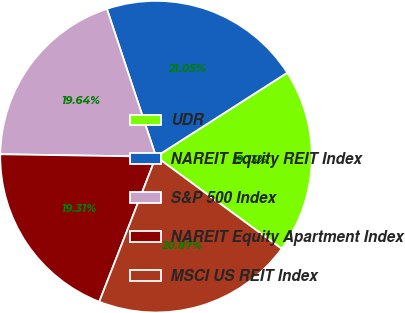Convert chart. <chart><loc_0><loc_0><loc_500><loc_500><pie_chart><fcel>UDR<fcel>NAREIT Equity REIT Index<fcel>S&P 500 Index<fcel>NAREIT Equity Apartment Index<fcel>MSCI US REIT Index<nl><fcel>19.13%<fcel>21.05%<fcel>19.64%<fcel>19.31%<fcel>20.87%<nl></chart> 